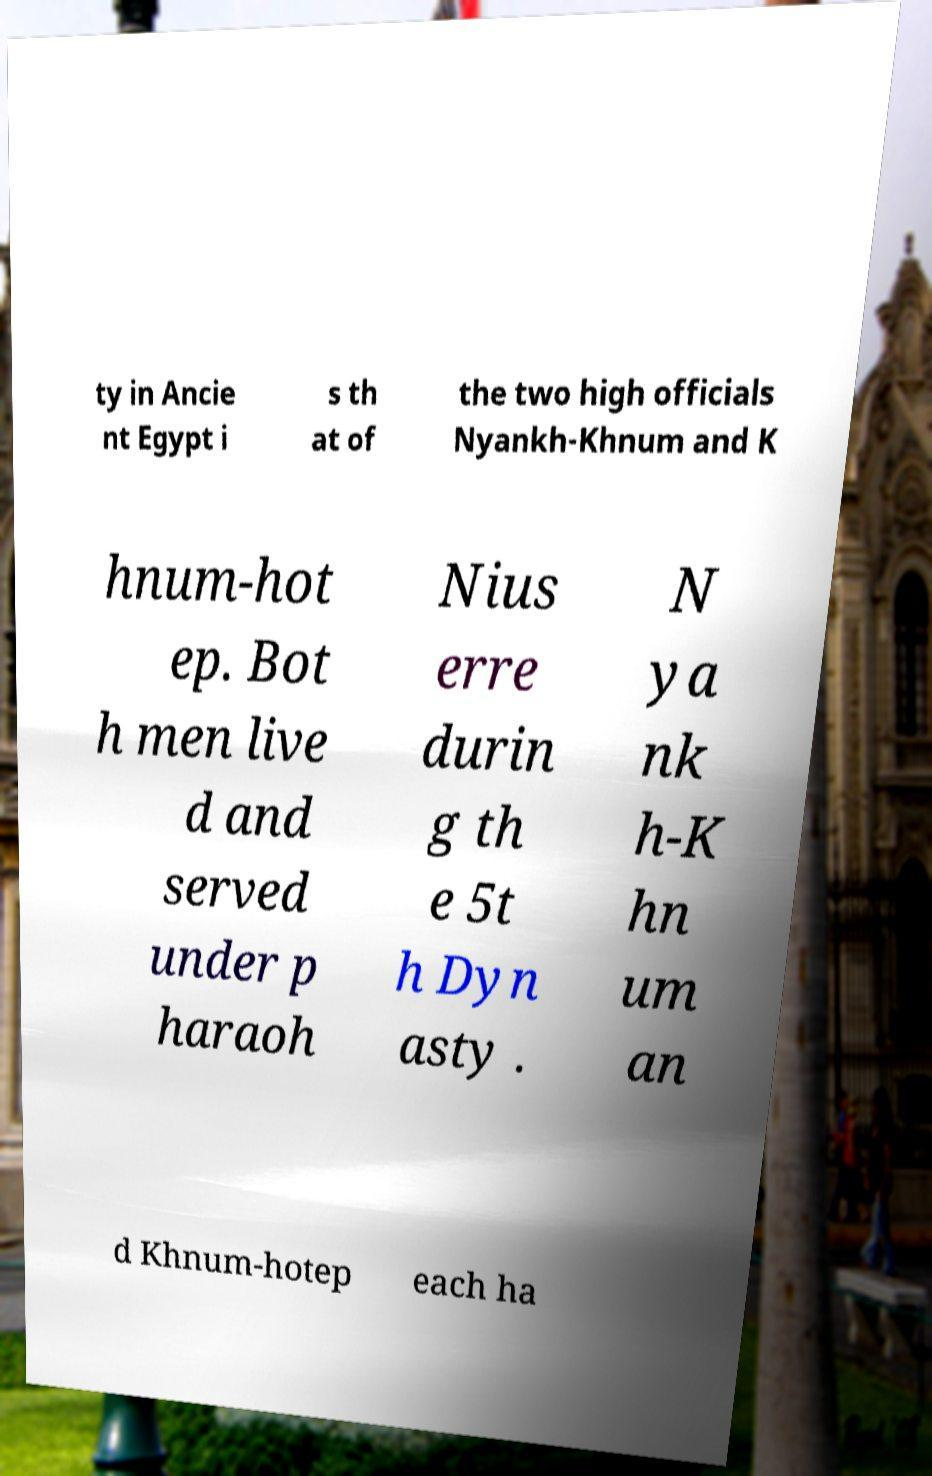For documentation purposes, I need the text within this image transcribed. Could you provide that? ty in Ancie nt Egypt i s th at of the two high officials Nyankh-Khnum and K hnum-hot ep. Bot h men live d and served under p haraoh Nius erre durin g th e 5t h Dyn asty . N ya nk h-K hn um an d Khnum-hotep each ha 